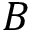Convert formula to latex. <formula><loc_0><loc_0><loc_500><loc_500>B</formula> 